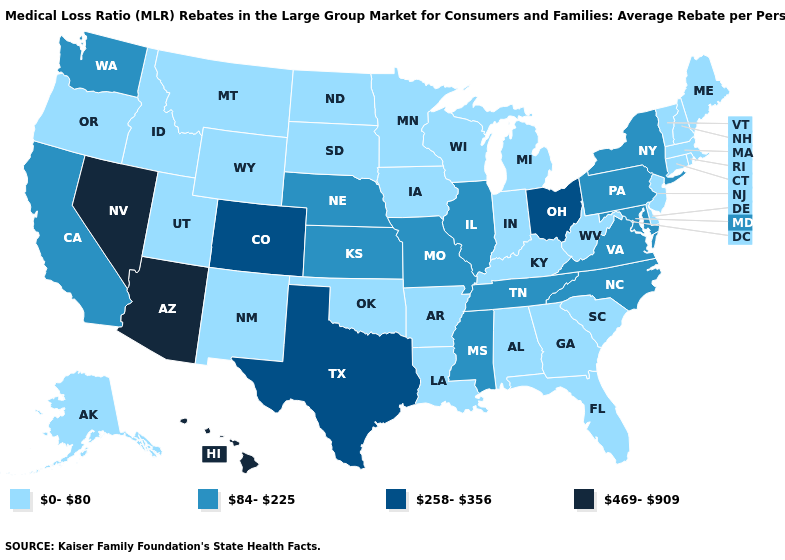Which states have the highest value in the USA?
Quick response, please. Arizona, Hawaii, Nevada. What is the value of Rhode Island?
Be succinct. 0-80. What is the value of Colorado?
Quick response, please. 258-356. Name the states that have a value in the range 469-909?
Give a very brief answer. Arizona, Hawaii, Nevada. What is the value of Arkansas?
Write a very short answer. 0-80. Does the map have missing data?
Concise answer only. No. What is the value of North Carolina?
Concise answer only. 84-225. What is the highest value in the Northeast ?
Give a very brief answer. 84-225. Which states have the lowest value in the USA?
Give a very brief answer. Alabama, Alaska, Arkansas, Connecticut, Delaware, Florida, Georgia, Idaho, Indiana, Iowa, Kentucky, Louisiana, Maine, Massachusetts, Michigan, Minnesota, Montana, New Hampshire, New Jersey, New Mexico, North Dakota, Oklahoma, Oregon, Rhode Island, South Carolina, South Dakota, Utah, Vermont, West Virginia, Wisconsin, Wyoming. Name the states that have a value in the range 0-80?
Concise answer only. Alabama, Alaska, Arkansas, Connecticut, Delaware, Florida, Georgia, Idaho, Indiana, Iowa, Kentucky, Louisiana, Maine, Massachusetts, Michigan, Minnesota, Montana, New Hampshire, New Jersey, New Mexico, North Dakota, Oklahoma, Oregon, Rhode Island, South Carolina, South Dakota, Utah, Vermont, West Virginia, Wisconsin, Wyoming. How many symbols are there in the legend?
Concise answer only. 4. Does Washington have a higher value than Wyoming?
Quick response, please. Yes. Does Missouri have the lowest value in the MidWest?
Concise answer only. No. Among the states that border California , does Arizona have the lowest value?
Answer briefly. No. What is the value of Kentucky?
Short answer required. 0-80. 